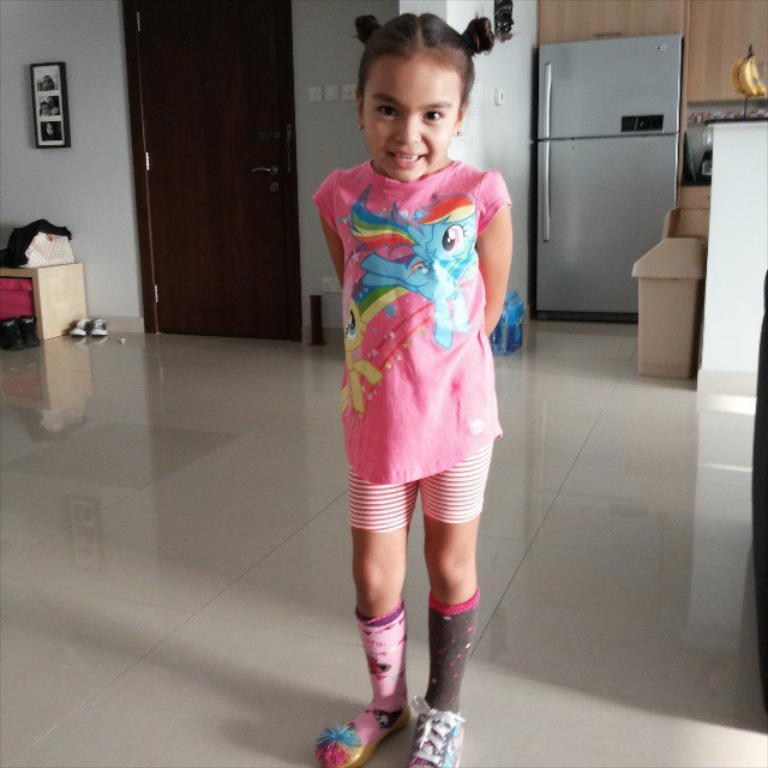What is the girl in the image wearing? The girl is wearing a pink dress. Can you describe the background of the image? There is a door, a fridge, shoes, and objects on the floor visible in the background. How is the image framed? The frame of the image is attached to the wall. What type of beast can be seen in the image? There is no beast present in the image; it features a girl standing in a room with a door, fridge, shoes, and objects on the floor. Who is the manager of the girl in the image? There is no indication of a manager or any hierarchical relationship in the image. 